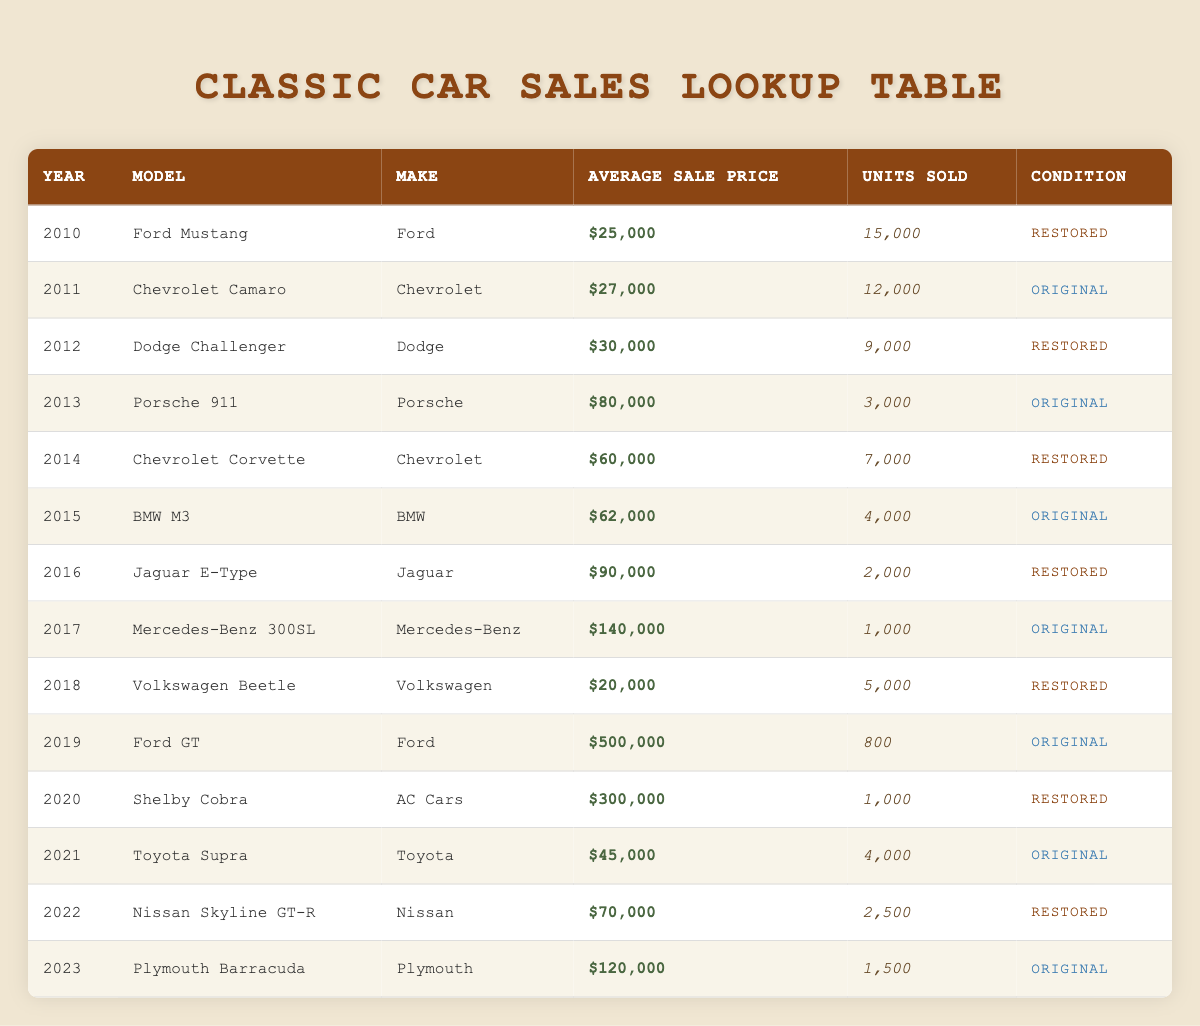What is the average sale price of the Ford Mustang in 2010? The average sale price is given directly in the table for the Ford Mustang in 2010, which is $25,000.
Answer: $25,000 How many units of the Chevrolet Camaro were sold in 2011? The table lists the units sold for the Chevrolet Camaro in 2011 as 12,000.
Answer: 12,000 Which car had the highest average sale price, and what was its price? By reviewing the average sale prices, the Ford GT in 2019 has the highest price at $500,000.
Answer: Ford GT at $500,000 What is the total number of units sold for all cars in the year 2012? Adding the units sold from the year 2012 from the table: Dodge Challenger has 9,000 units. Therefore, the total for 2012 is 9,000.
Answer: 9,000 Is the Chevrolet Corvette from 2014 in original condition? The table states that the Chevrolet Corvette from 2014 is classified as 'Restored', therefore the claim is false.
Answer: No Which model has the lowest average sale price and what is that price? The Volkswagen Beetle from 2018 has the lowest average sale price at $20,000.
Answer: Volkswagen Beetle at $20,000 What percentage of units sold were for original cars from 2014 to 2023? From 2014 to 2023, counting the original cars: Chevrolet Corvette (7,000), BMW M3 (4,000), Mercedes-Benz 300SL (1,000), Ford GT (800), Toyota Supra (4,000), and Plymouth Barracuda (1,500). The total units sold for original cars is 18,300 out of 40,300 total units sold (using total from all years 2010-2023). The percentage is (18,300 / 40,300) * 100 = 45.4%.
Answer: 45.4% Did more than 10,000 units of any car sell in the year 2015? In 2015, 4,000 units of the BMW M3 were sold which is less than 10,000. Therefore, the answer is no.
Answer: No What is the difference in average sale price between the Jaguar E-Type and the Plymouth Barracuda? The Jaguar E-Type from 2016 has an average sale price of $90,000 and the Plymouth Barracuda from 2023 is $120,000. The difference is $120,000 - $90,000 = $30,000.
Answer: $30,000 